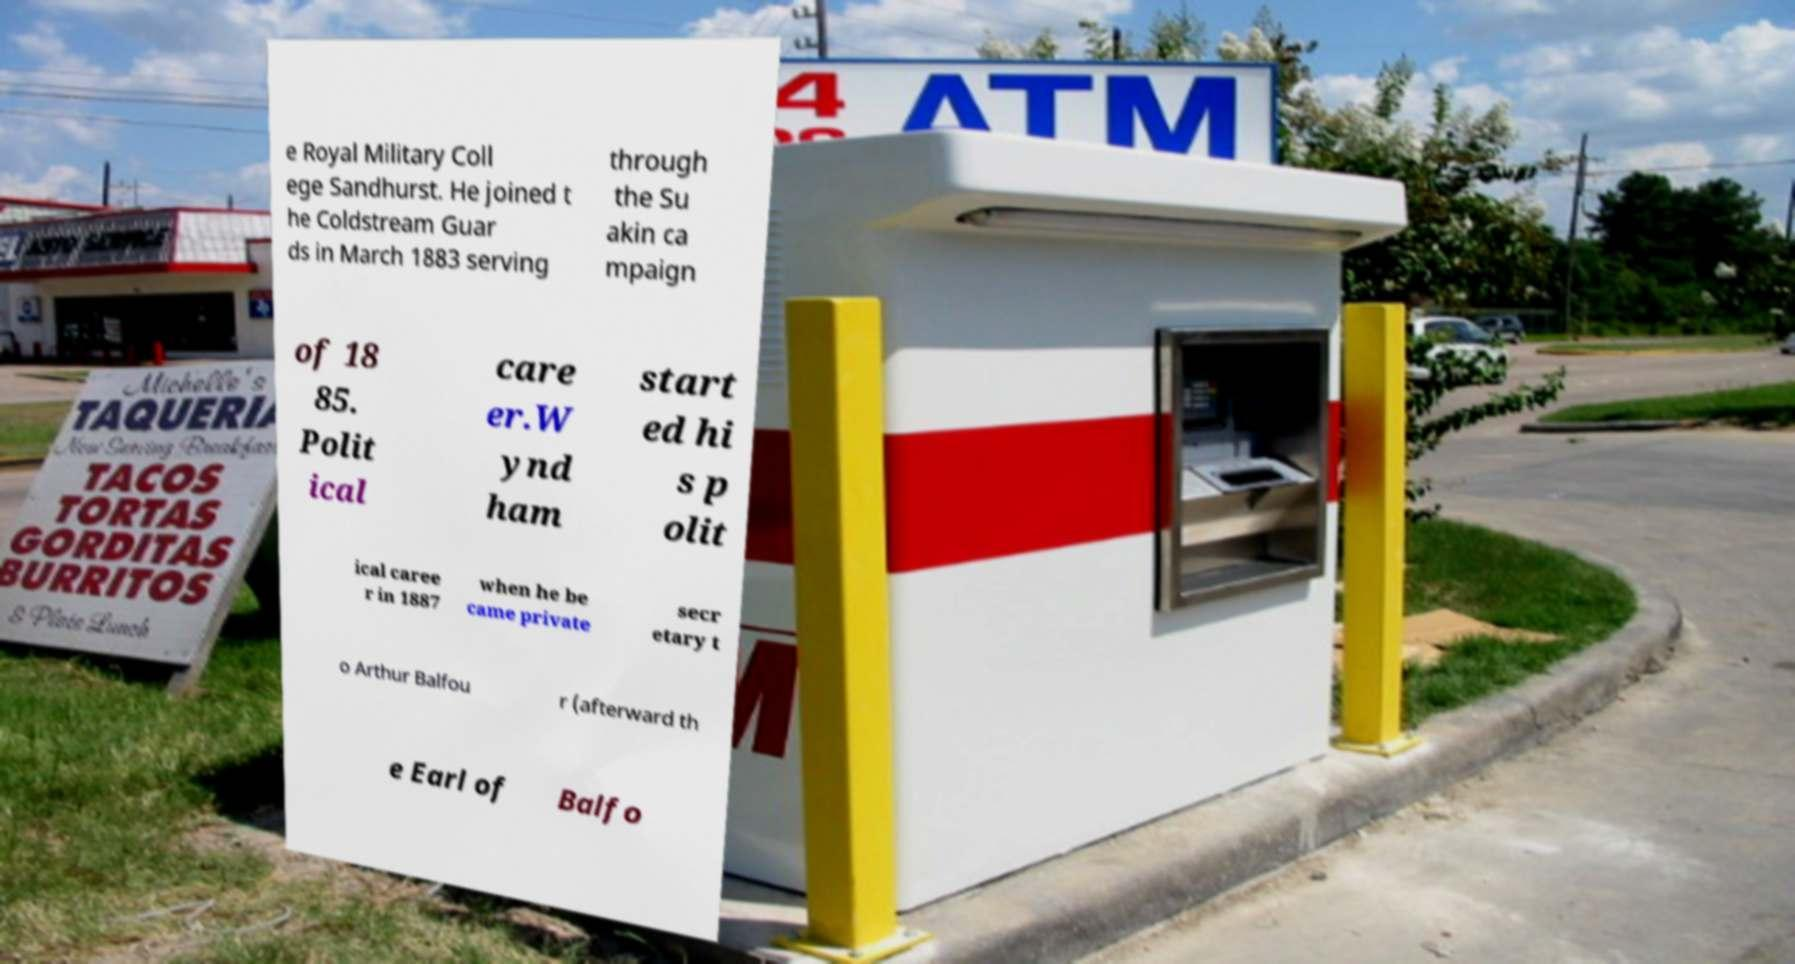There's text embedded in this image that I need extracted. Can you transcribe it verbatim? e Royal Military Coll ege Sandhurst. He joined t he Coldstream Guar ds in March 1883 serving through the Su akin ca mpaign of 18 85. Polit ical care er.W ynd ham start ed hi s p olit ical caree r in 1887 when he be came private secr etary t o Arthur Balfou r (afterward th e Earl of Balfo 